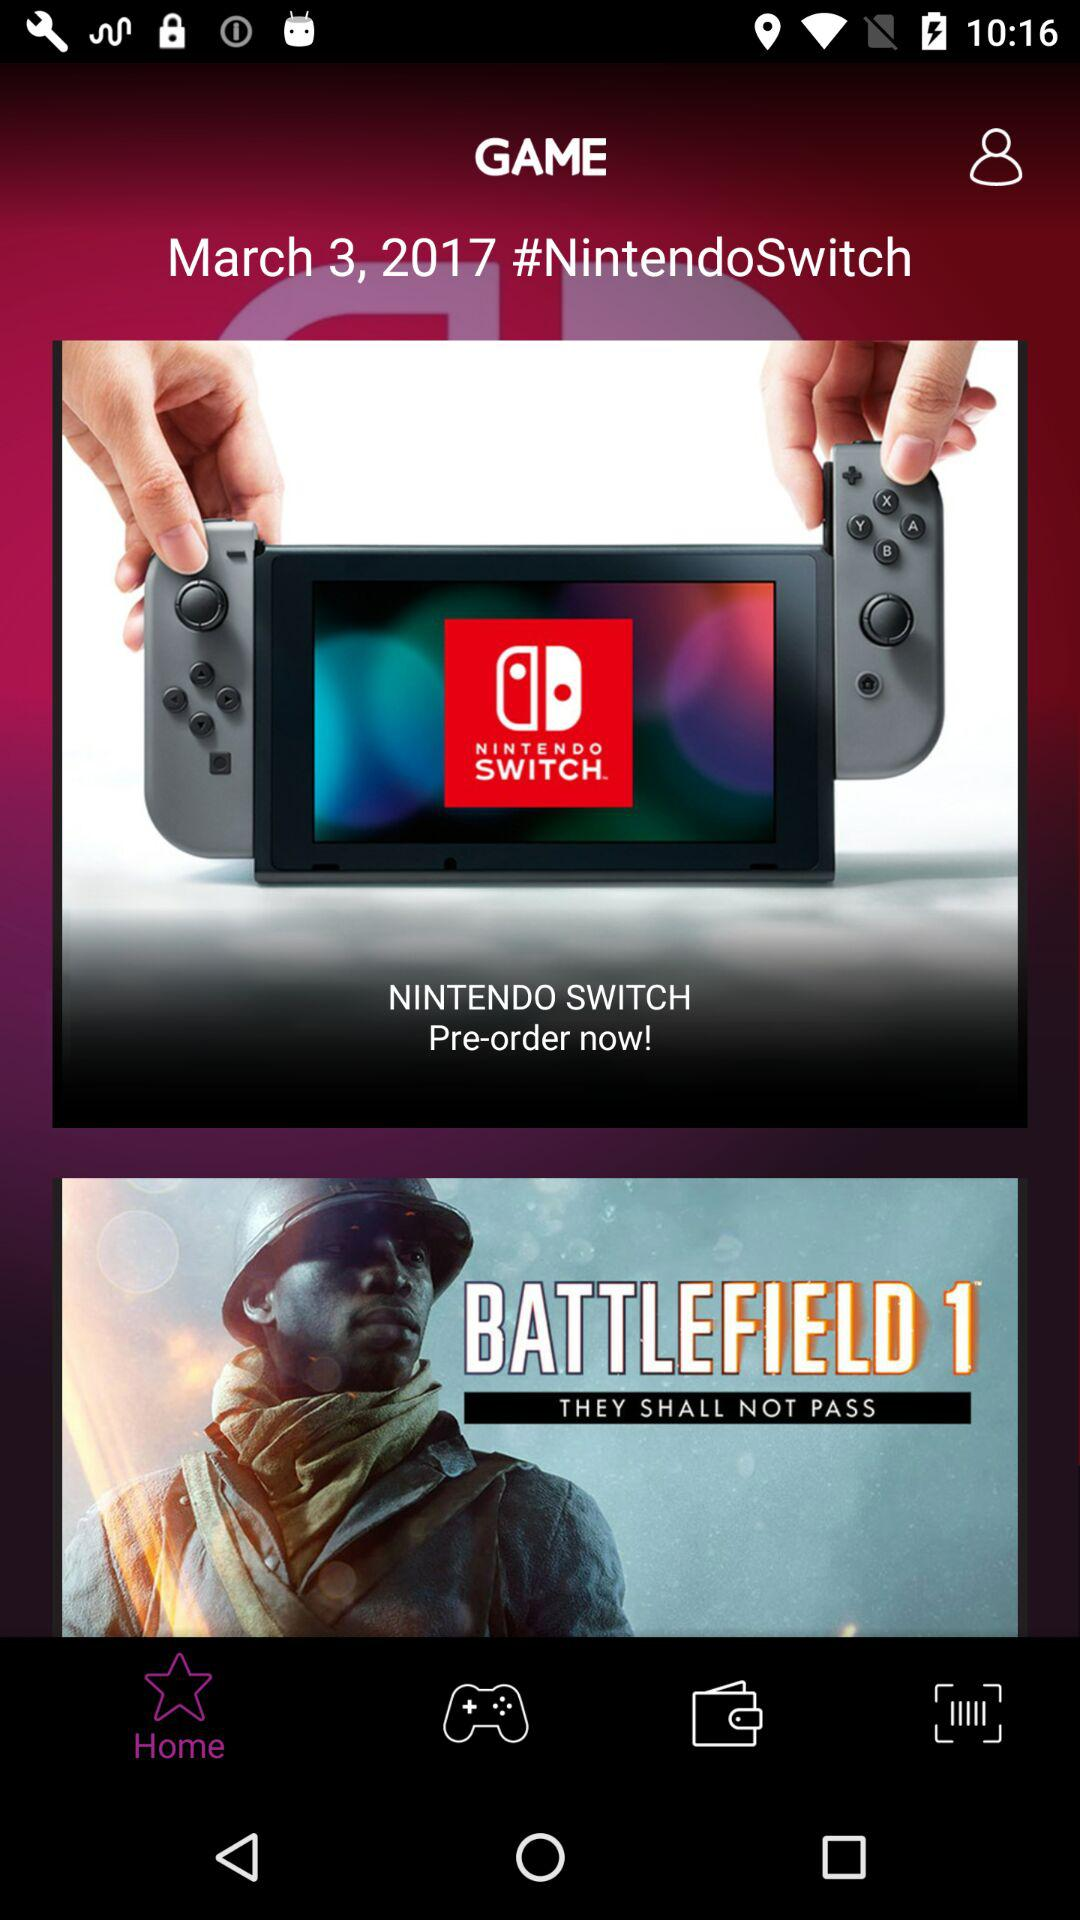Which tab has been selected? The selected tab is "Home". 